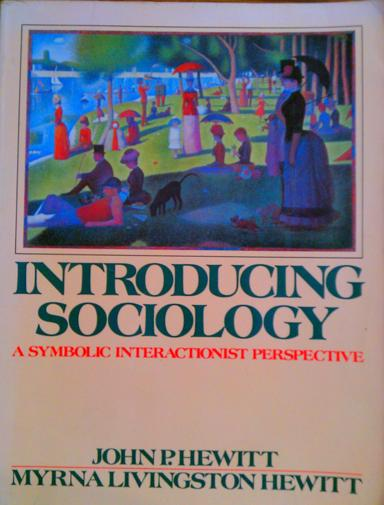What is the title of the book mentioned in the image? The book depicted in the image is titled 'Introducing Sociology: A Symbolic Interactionist Perspective'. It is authored by John P. Hewitt and Myrna Livingston Hewitt, offering an extensive exploration into sociology through the lens of symbolic interactionism. 